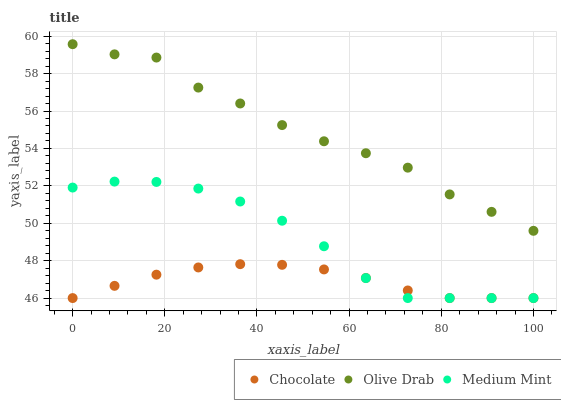Does Chocolate have the minimum area under the curve?
Answer yes or no. Yes. Does Olive Drab have the maximum area under the curve?
Answer yes or no. Yes. Does Olive Drab have the minimum area under the curve?
Answer yes or no. No. Does Chocolate have the maximum area under the curve?
Answer yes or no. No. Is Chocolate the smoothest?
Answer yes or no. Yes. Is Olive Drab the roughest?
Answer yes or no. Yes. Is Olive Drab the smoothest?
Answer yes or no. No. Is Chocolate the roughest?
Answer yes or no. No. Does Medium Mint have the lowest value?
Answer yes or no. Yes. Does Olive Drab have the lowest value?
Answer yes or no. No. Does Olive Drab have the highest value?
Answer yes or no. Yes. Does Chocolate have the highest value?
Answer yes or no. No. Is Chocolate less than Olive Drab?
Answer yes or no. Yes. Is Olive Drab greater than Medium Mint?
Answer yes or no. Yes. Does Chocolate intersect Medium Mint?
Answer yes or no. Yes. Is Chocolate less than Medium Mint?
Answer yes or no. No. Is Chocolate greater than Medium Mint?
Answer yes or no. No. Does Chocolate intersect Olive Drab?
Answer yes or no. No. 